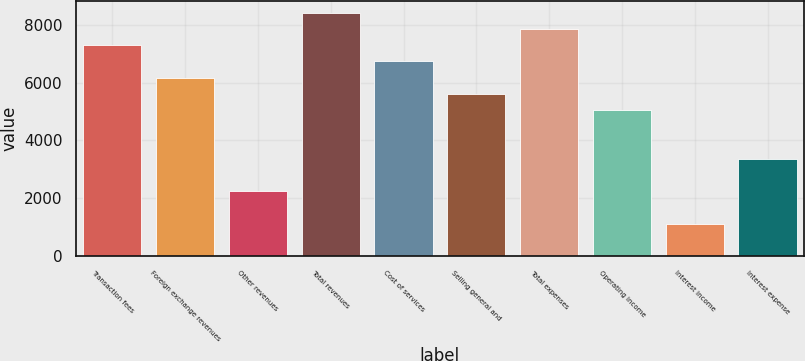<chart> <loc_0><loc_0><loc_500><loc_500><bar_chart><fcel>Transaction fees<fcel>Foreign exchange revenues<fcel>Other revenues<fcel>Total revenues<fcel>Cost of services<fcel>Selling general and<fcel>Total expenses<fcel>Operating income<fcel>Interest income<fcel>Interest expense<nl><fcel>7288.87<fcel>6167.75<fcel>2243.83<fcel>8409.99<fcel>6728.31<fcel>5607.19<fcel>7849.43<fcel>5046.63<fcel>1122.71<fcel>3364.95<nl></chart> 